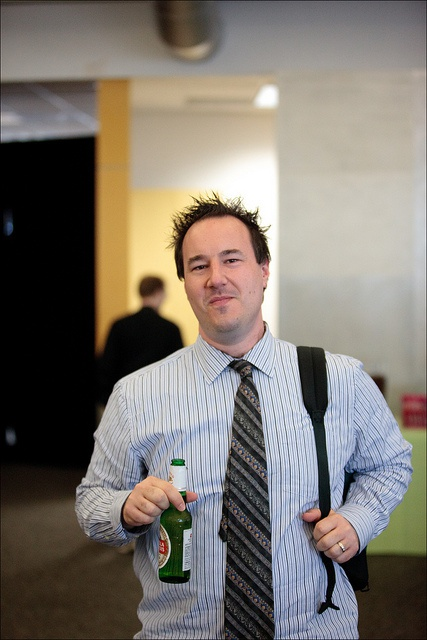Describe the objects in this image and their specific colors. I can see people in black, darkgray, and lightgray tones, tie in black and gray tones, people in black, maroon, and gray tones, backpack in black, gray, and darkgray tones, and bottle in black, lightgray, darkgray, and darkgreen tones in this image. 